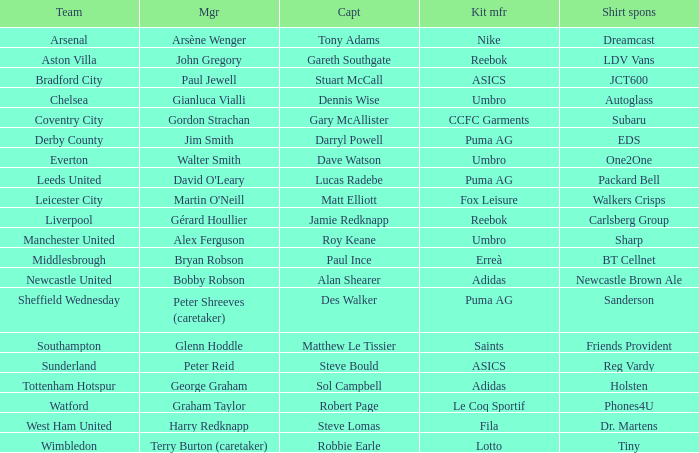Which shirt sponsor has nike as their provider for kits? Dreamcast. 